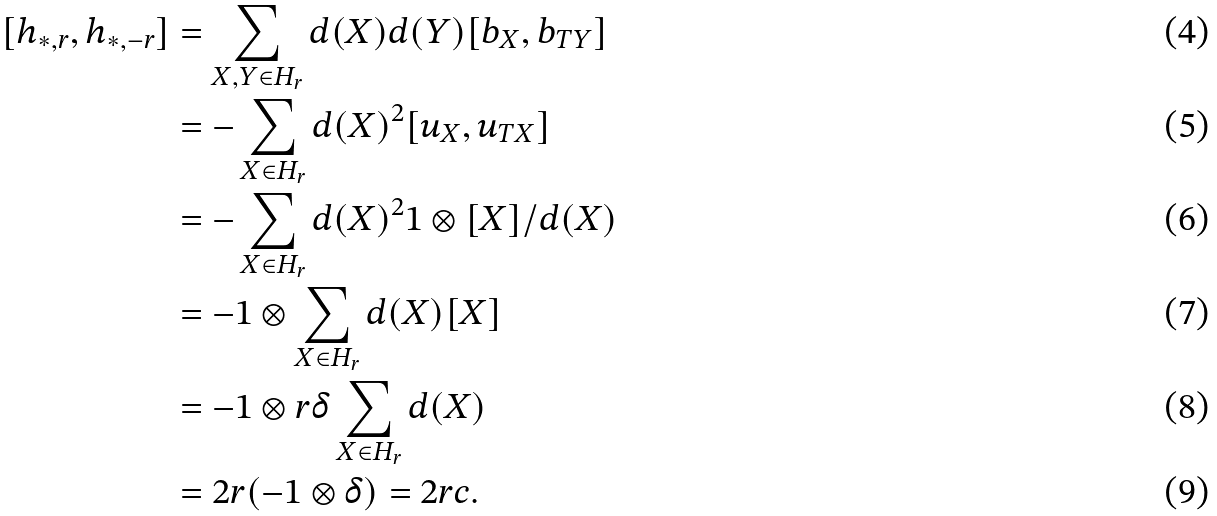<formula> <loc_0><loc_0><loc_500><loc_500>[ h _ { * , r } , h _ { * , - r } ] & = \sum _ { X , Y \in H _ { r } } d ( X ) d ( Y ) [ b _ { X } , b _ { T Y } ] \\ & = - \sum _ { X \in H _ { r } } d ( X ) ^ { 2 } [ u _ { X } , u _ { T X } ] \\ & = - \sum _ { X \in H _ { r } } d ( X ) ^ { 2 } 1 \otimes [ X ] / d ( X ) \\ & = - 1 \otimes \sum _ { X \in H _ { r } } d ( X ) [ X ] \\ & = - 1 \otimes r \delta \sum _ { X \in H _ { r } } d ( X ) \\ & = 2 r ( - 1 \otimes \delta ) = 2 r c .</formula> 